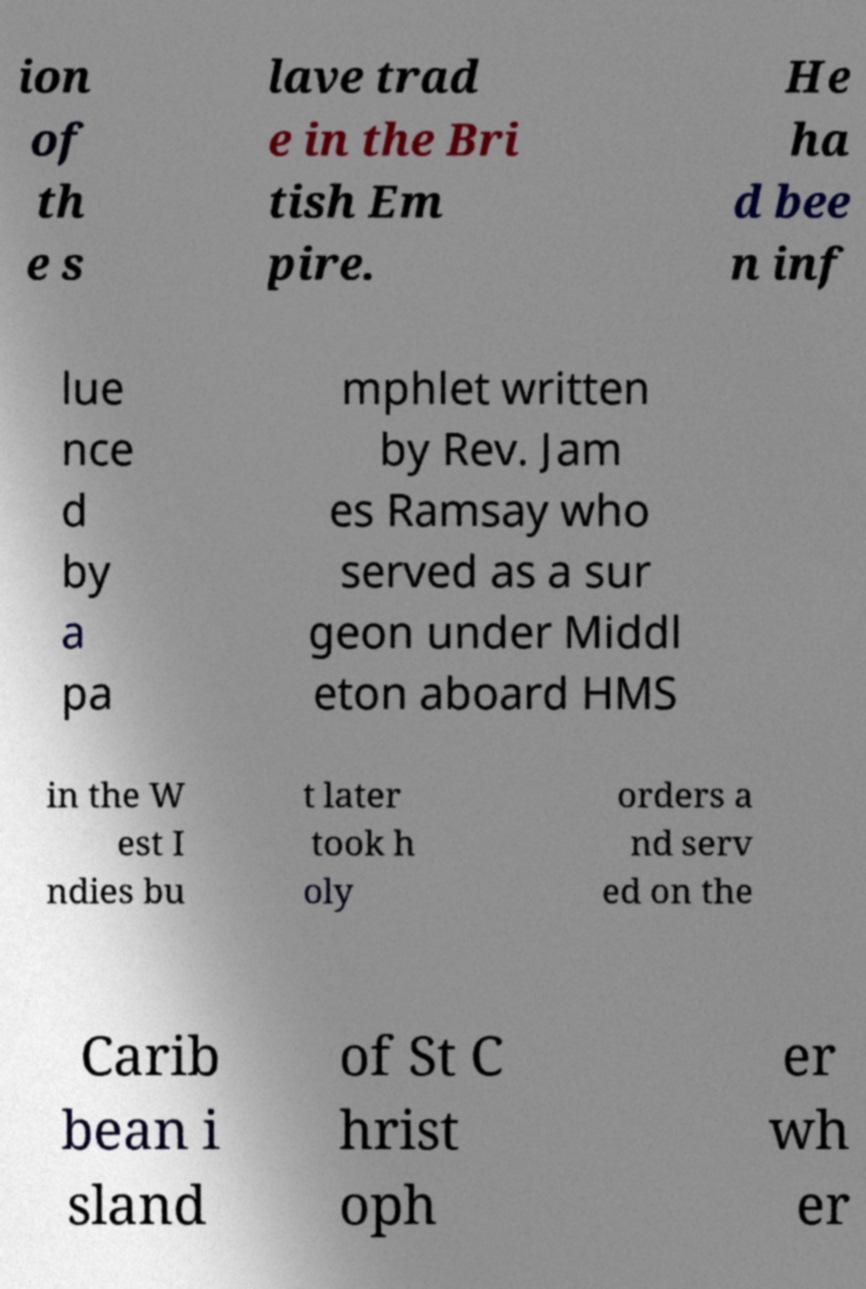What messages or text are displayed in this image? I need them in a readable, typed format. ion of th e s lave trad e in the Bri tish Em pire. He ha d bee n inf lue nce d by a pa mphlet written by Rev. Jam es Ramsay who served as a sur geon under Middl eton aboard HMS in the W est I ndies bu t later took h oly orders a nd serv ed on the Carib bean i sland of St C hrist oph er wh er 